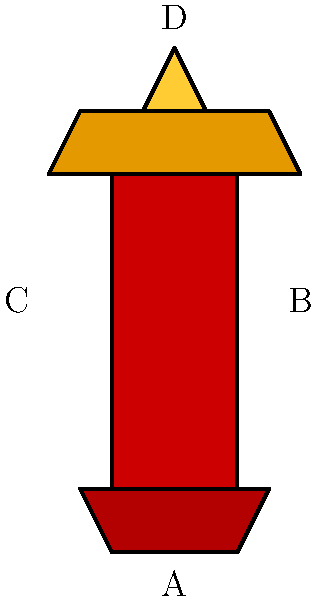Which superhero costume design element best complements Mayling Ng's strong physique and would enhance her on-screen presence in an action-packed role? To answer this question, we need to consider Mayling Ng's physical attributes and how they align with superhero costume elements:

1. Mayling Ng is known for her strong, athletic build and martial arts prowess.
2. Element A (boots) adds power to the lower body but doesn't highlight her overall strength.
3. Element B (body) is a basic form-fitting design that shows physique but lacks distinctiveness.
4. Element C (shoulder pads) emphasizes upper body strength and creates a powerful silhouette.
5. Element D (helmet/headpiece) focuses on head protection but doesn't showcase physical attributes.

Given Mayling Ng's strong physique, element C (shoulder pads) would best complement her attributes by:
- Accentuating her upper body strength
- Creating a more imposing and powerful silhouette
- Aligning with her action-oriented roles and martial arts background

This design choice would enhance her on-screen presence and reinforce her image as a formidable action star.
Answer: C (shoulder pads) 